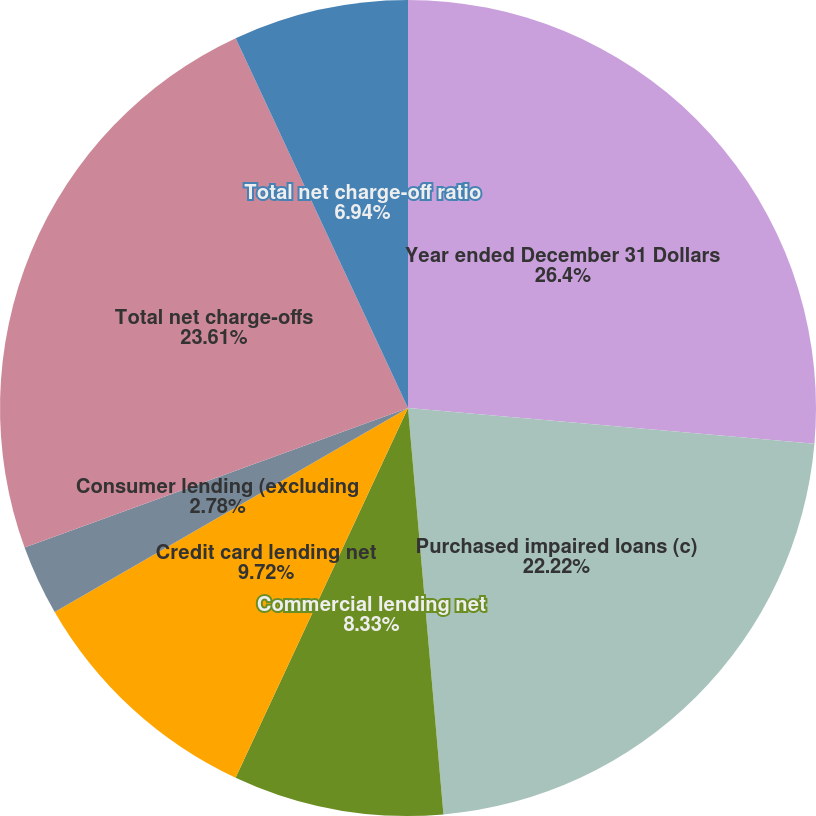Convert chart to OTSL. <chart><loc_0><loc_0><loc_500><loc_500><pie_chart><fcel>Year ended December 31 Dollars<fcel>Purchased impaired loans (c)<fcel>Commercial lending net<fcel>Credit card lending net<fcel>Consumer lending (excluding<fcel>Total net charge-offs<fcel>Total net charge-off ratio<nl><fcel>26.39%<fcel>22.22%<fcel>8.33%<fcel>9.72%<fcel>2.78%<fcel>23.61%<fcel>6.94%<nl></chart> 